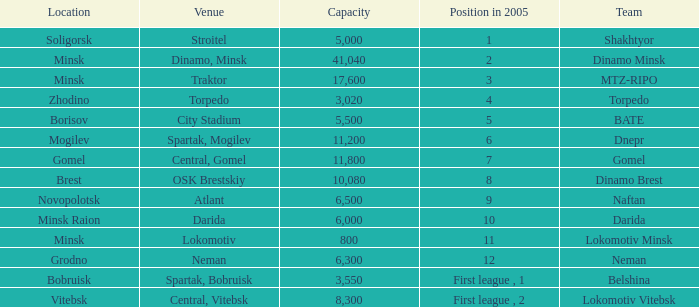Can you tell me the Venue that has the Position in 2005 of 8? OSK Brestskiy. 